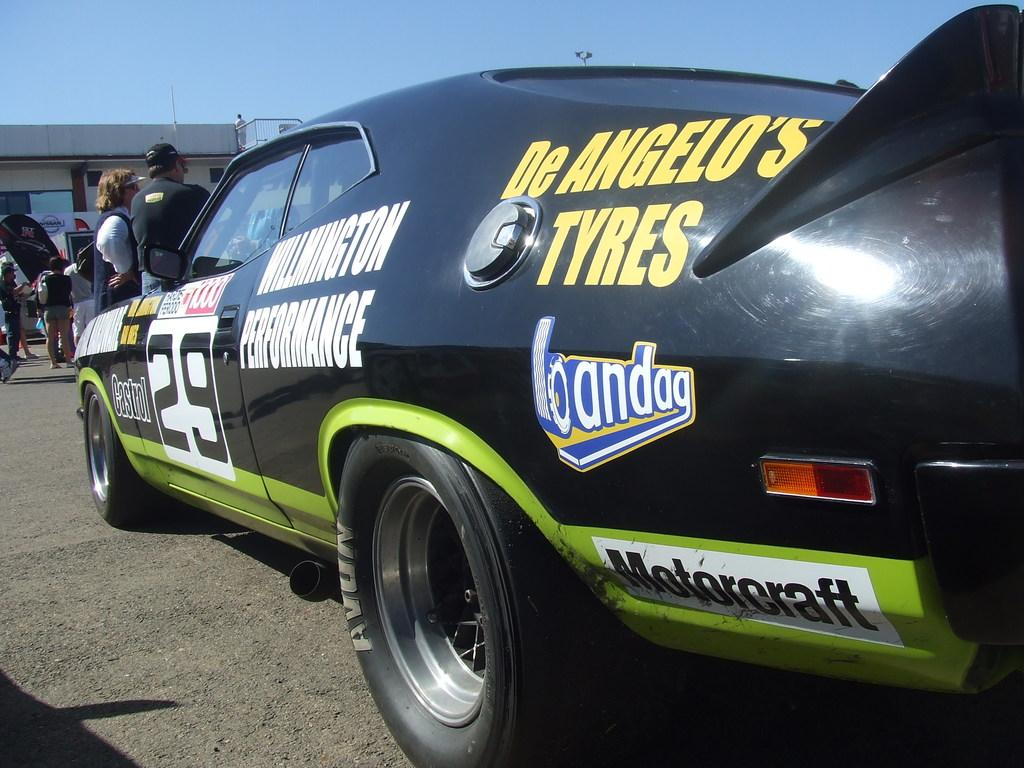What type of vehicle is in the image? There is a black car in the image. Who or what is in front of the car? People are in front of the car. What can be seen in the background of the image? There is a building in the background of the image. What part of the natural environment is visible in the image? The sky is visible above the building. What language is the squirrel speaking in the image? There is no squirrel present in the image, so it is not possible to determine what language it might be speaking. 